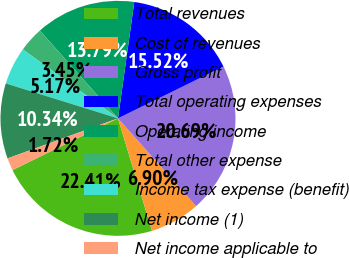Convert chart to OTSL. <chart><loc_0><loc_0><loc_500><loc_500><pie_chart><fcel>Total revenues<fcel>Cost of revenues<fcel>Gross profit<fcel>Total operating expenses<fcel>Operating income<fcel>Total other expense<fcel>Income tax expense (benefit)<fcel>Net income (1)<fcel>Net income applicable to<nl><fcel>22.41%<fcel>6.9%<fcel>20.69%<fcel>15.52%<fcel>13.79%<fcel>3.45%<fcel>5.17%<fcel>10.34%<fcel>1.72%<nl></chart> 